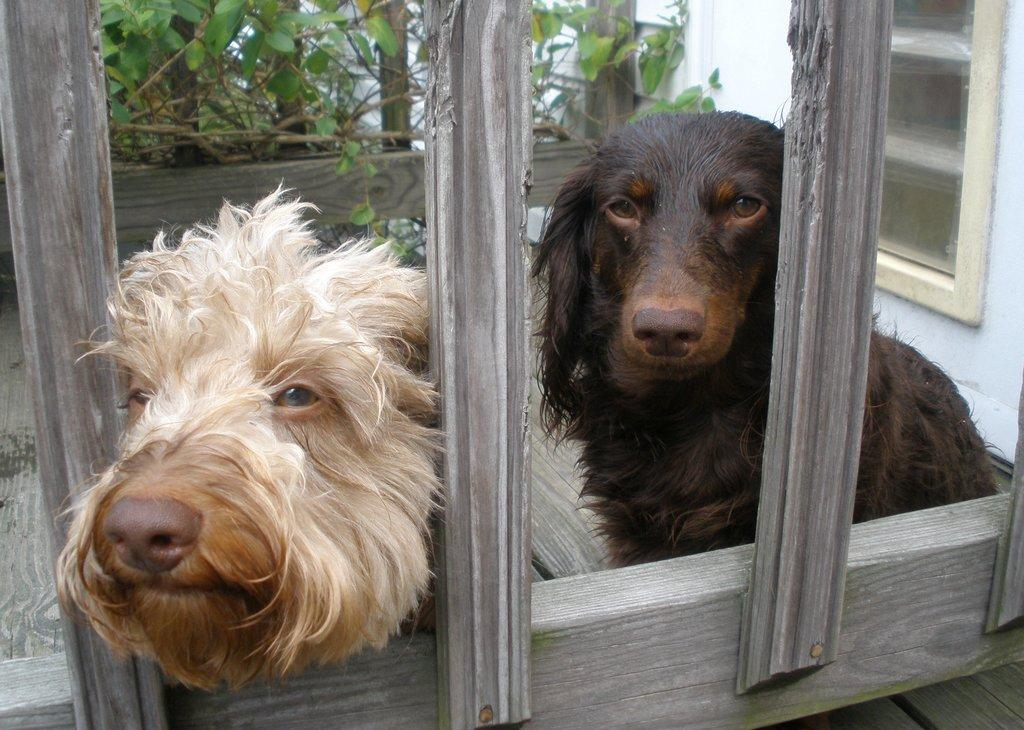How many dogs are in the image? There are two dogs in the image. What is in front of the dogs? There is a wooden fence in front of the dogs. What can be seen behind the dogs? There are plants visible behind the dogs. What architectural feature is present in the background of the image? There is a wall with a window in the background of the image. What type of water is the dogs playing with in the image? There is no water present in the image; the dogs are in front of a wooden fence with plants behind them. 